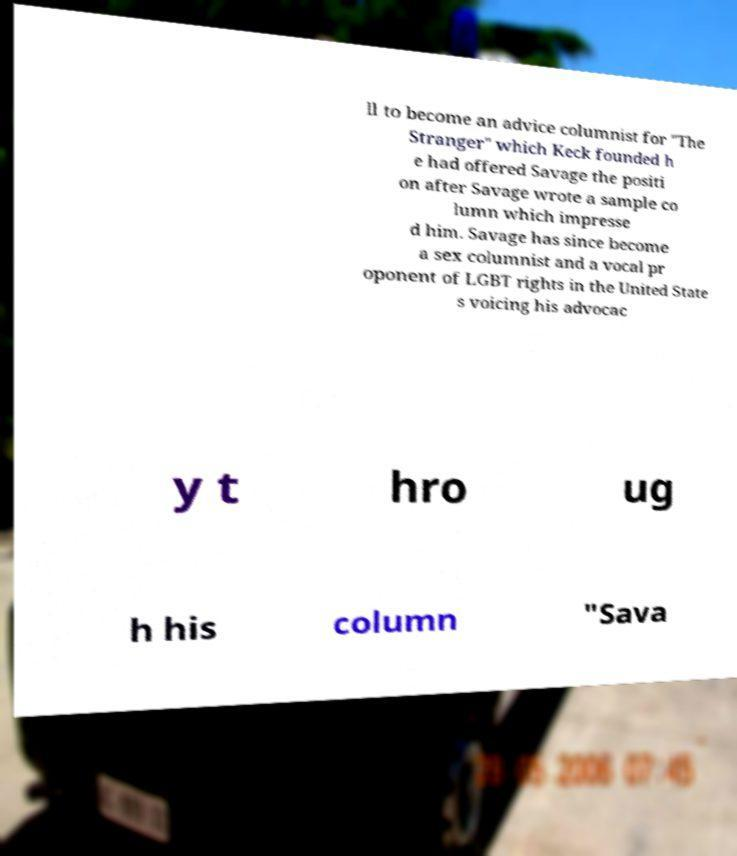What messages or text are displayed in this image? I need them in a readable, typed format. ll to become an advice columnist for "The Stranger" which Keck founded h e had offered Savage the positi on after Savage wrote a sample co lumn which impresse d him. Savage has since become a sex columnist and a vocal pr oponent of LGBT rights in the United State s voicing his advocac y t hro ug h his column "Sava 